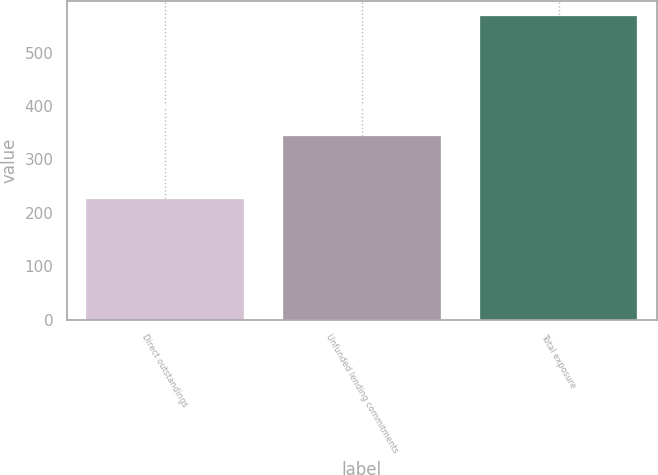Convert chart. <chart><loc_0><loc_0><loc_500><loc_500><bar_chart><fcel>Direct outstandings<fcel>Unfunded lending commitments<fcel>Total exposure<nl><fcel>225<fcel>344<fcel>569<nl></chart> 